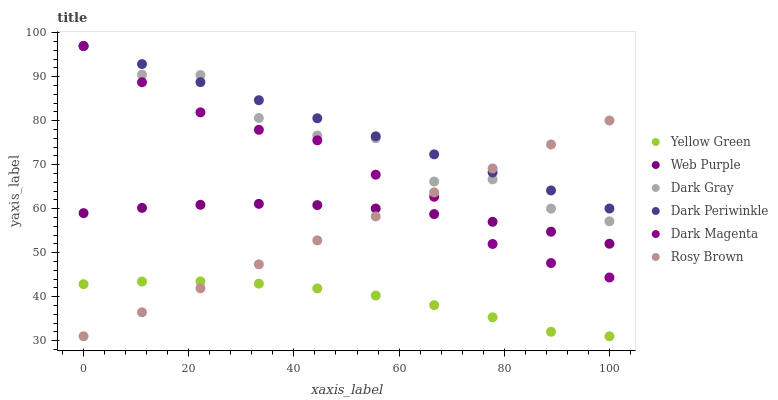Does Yellow Green have the minimum area under the curve?
Answer yes or no. Yes. Does Dark Periwinkle have the maximum area under the curve?
Answer yes or no. Yes. Does Rosy Brown have the minimum area under the curve?
Answer yes or no. No. Does Rosy Brown have the maximum area under the curve?
Answer yes or no. No. Is Dark Periwinkle the smoothest?
Answer yes or no. Yes. Is Dark Gray the roughest?
Answer yes or no. Yes. Is Rosy Brown the smoothest?
Answer yes or no. No. Is Rosy Brown the roughest?
Answer yes or no. No. Does Yellow Green have the lowest value?
Answer yes or no. Yes. Does Dark Gray have the lowest value?
Answer yes or no. No. Does Dark Magenta have the highest value?
Answer yes or no. Yes. Does Rosy Brown have the highest value?
Answer yes or no. No. Is Web Purple less than Dark Gray?
Answer yes or no. Yes. Is Dark Periwinkle greater than Yellow Green?
Answer yes or no. Yes. Does Dark Periwinkle intersect Dark Gray?
Answer yes or no. Yes. Is Dark Periwinkle less than Dark Gray?
Answer yes or no. No. Is Dark Periwinkle greater than Dark Gray?
Answer yes or no. No. Does Web Purple intersect Dark Gray?
Answer yes or no. No. 